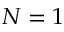<formula> <loc_0><loc_0><loc_500><loc_500>N = 1</formula> 